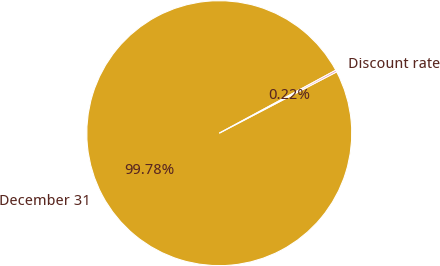Convert chart. <chart><loc_0><loc_0><loc_500><loc_500><pie_chart><fcel>December 31<fcel>Discount rate<nl><fcel>99.78%<fcel>0.22%<nl></chart> 